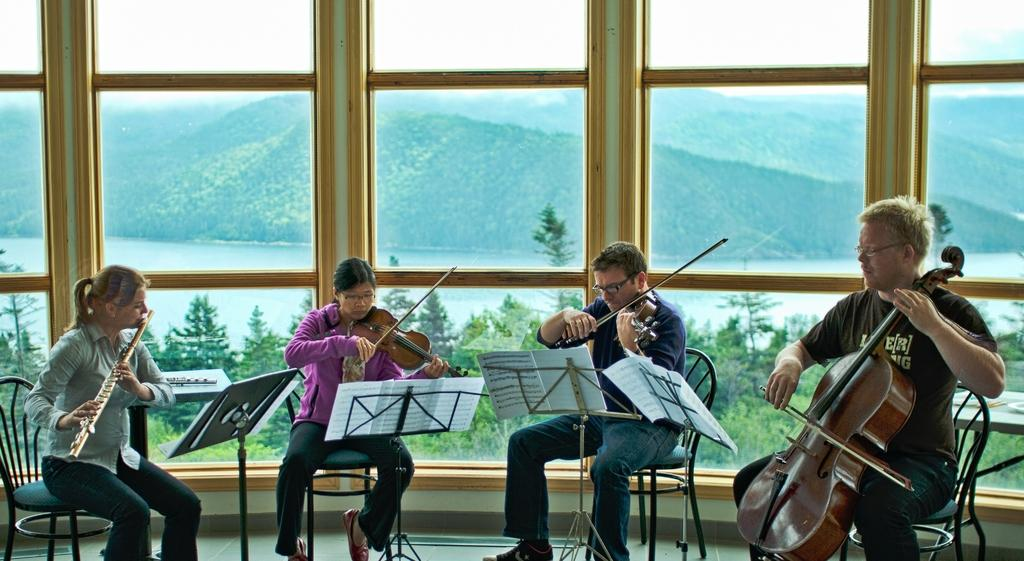How many people are in the image? There are four persons in the image. What are the persons doing in the image? The persons are sitting on chairs and holding musical instruments. What can be seen in the background of the image? There is a hill, glass, water, trees, grass, and a plant visible in the background. What type of tank can be seen in the image? There is no tank present in the image. Is there a camp visible in the image? There is no camp visible in the image. 